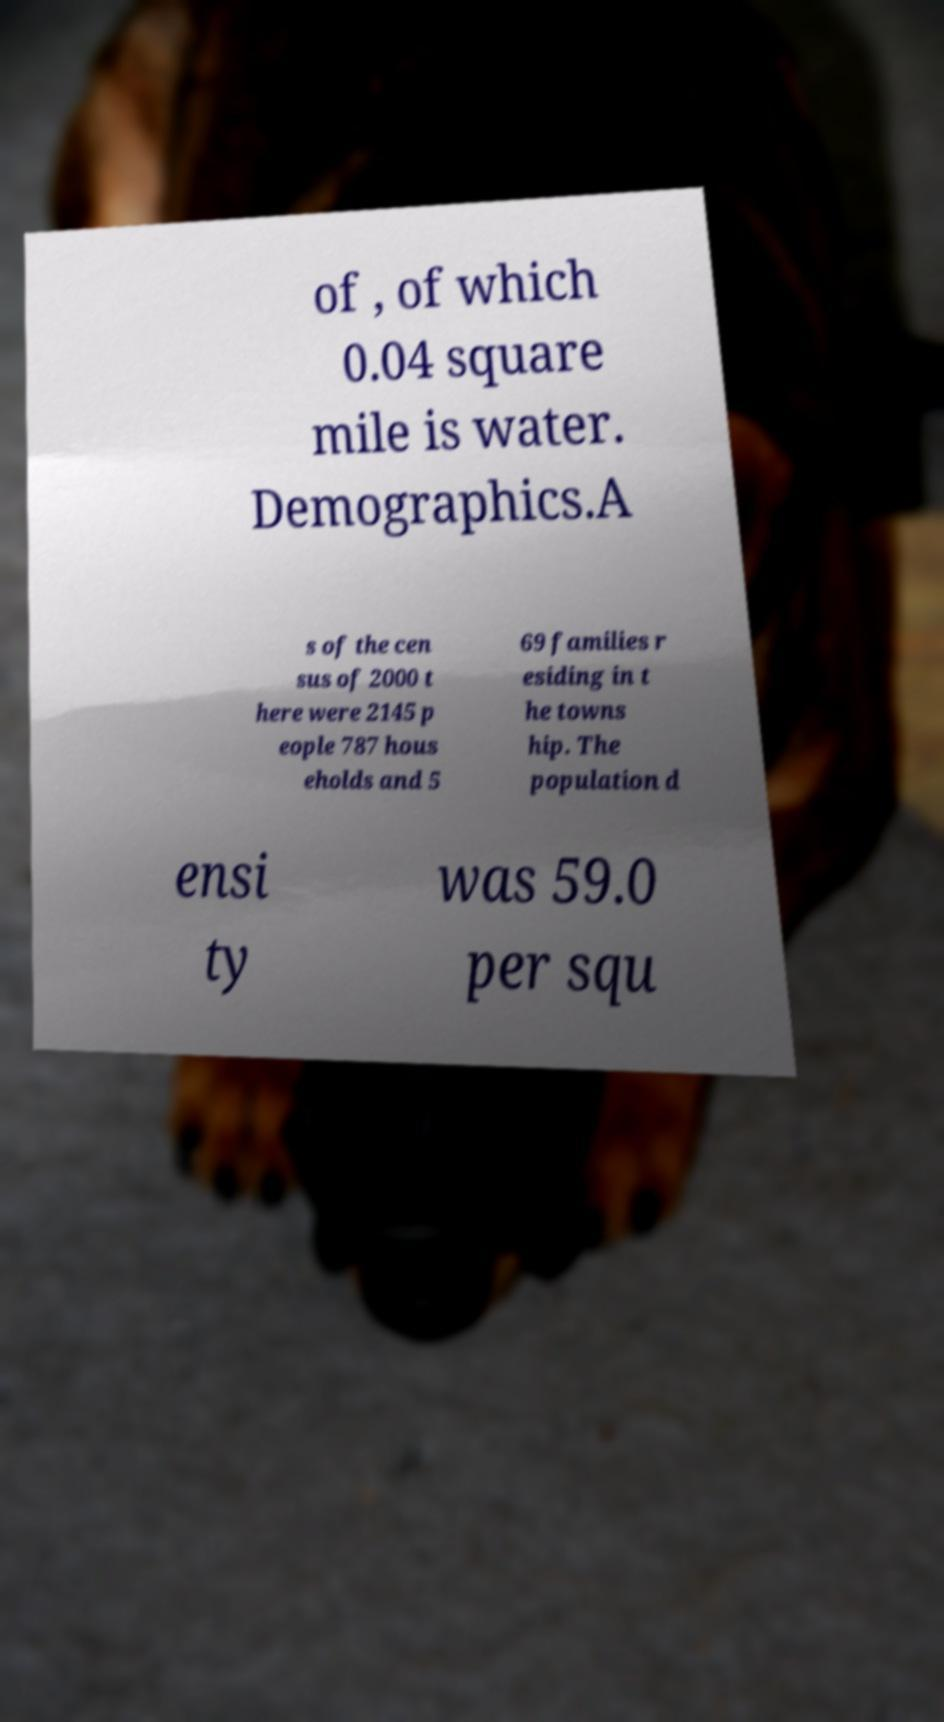What messages or text are displayed in this image? I need them in a readable, typed format. of , of which 0.04 square mile is water. Demographics.A s of the cen sus of 2000 t here were 2145 p eople 787 hous eholds and 5 69 families r esiding in t he towns hip. The population d ensi ty was 59.0 per squ 